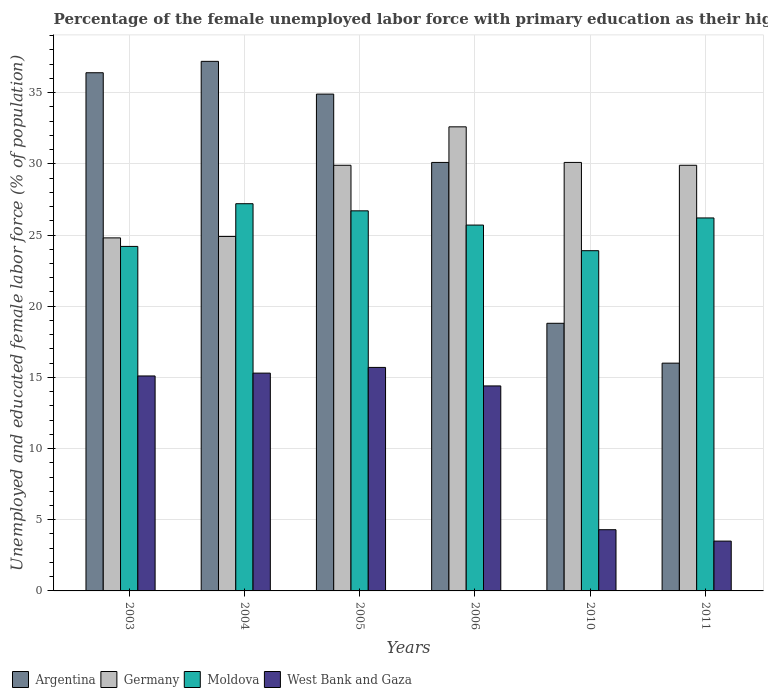How many different coloured bars are there?
Ensure brevity in your answer.  4. How many groups of bars are there?
Provide a short and direct response. 6. Are the number of bars on each tick of the X-axis equal?
Offer a terse response. Yes. How many bars are there on the 5th tick from the left?
Your answer should be compact. 4. What is the percentage of the unemployed female labor force with primary education in West Bank and Gaza in 2003?
Make the answer very short. 15.1. Across all years, what is the maximum percentage of the unemployed female labor force with primary education in Germany?
Ensure brevity in your answer.  32.6. In which year was the percentage of the unemployed female labor force with primary education in Moldova minimum?
Your response must be concise. 2010. What is the total percentage of the unemployed female labor force with primary education in West Bank and Gaza in the graph?
Your response must be concise. 68.3. What is the difference between the percentage of the unemployed female labor force with primary education in West Bank and Gaza in 2005 and that in 2011?
Provide a short and direct response. 12.2. What is the difference between the percentage of the unemployed female labor force with primary education in Germany in 2010 and the percentage of the unemployed female labor force with primary education in West Bank and Gaza in 2004?
Your answer should be very brief. 14.8. What is the average percentage of the unemployed female labor force with primary education in Moldova per year?
Ensure brevity in your answer.  25.65. In the year 2006, what is the difference between the percentage of the unemployed female labor force with primary education in Moldova and percentage of the unemployed female labor force with primary education in Argentina?
Keep it short and to the point. -4.4. In how many years, is the percentage of the unemployed female labor force with primary education in Germany greater than 28 %?
Provide a succinct answer. 4. What is the ratio of the percentage of the unemployed female labor force with primary education in West Bank and Gaza in 2010 to that in 2011?
Your answer should be very brief. 1.23. Is the difference between the percentage of the unemployed female labor force with primary education in Moldova in 2003 and 2006 greater than the difference between the percentage of the unemployed female labor force with primary education in Argentina in 2003 and 2006?
Provide a short and direct response. No. What is the difference between the highest and the second highest percentage of the unemployed female labor force with primary education in Moldova?
Keep it short and to the point. 0.5. What is the difference between the highest and the lowest percentage of the unemployed female labor force with primary education in Moldova?
Offer a very short reply. 3.3. Is it the case that in every year, the sum of the percentage of the unemployed female labor force with primary education in West Bank and Gaza and percentage of the unemployed female labor force with primary education in Argentina is greater than the sum of percentage of the unemployed female labor force with primary education in Germany and percentage of the unemployed female labor force with primary education in Moldova?
Keep it short and to the point. No. What does the 1st bar from the left in 2005 represents?
Ensure brevity in your answer.  Argentina. What is the difference between two consecutive major ticks on the Y-axis?
Your answer should be compact. 5. Where does the legend appear in the graph?
Keep it short and to the point. Bottom left. How many legend labels are there?
Keep it short and to the point. 4. How are the legend labels stacked?
Give a very brief answer. Horizontal. What is the title of the graph?
Provide a succinct answer. Percentage of the female unemployed labor force with primary education as their highest grade. What is the label or title of the X-axis?
Offer a terse response. Years. What is the label or title of the Y-axis?
Provide a succinct answer. Unemployed and educated female labor force (% of population). What is the Unemployed and educated female labor force (% of population) of Argentina in 2003?
Make the answer very short. 36.4. What is the Unemployed and educated female labor force (% of population) in Germany in 2003?
Keep it short and to the point. 24.8. What is the Unemployed and educated female labor force (% of population) in Moldova in 2003?
Give a very brief answer. 24.2. What is the Unemployed and educated female labor force (% of population) in West Bank and Gaza in 2003?
Offer a terse response. 15.1. What is the Unemployed and educated female labor force (% of population) of Argentina in 2004?
Your answer should be very brief. 37.2. What is the Unemployed and educated female labor force (% of population) of Germany in 2004?
Offer a very short reply. 24.9. What is the Unemployed and educated female labor force (% of population) in Moldova in 2004?
Offer a very short reply. 27.2. What is the Unemployed and educated female labor force (% of population) of West Bank and Gaza in 2004?
Ensure brevity in your answer.  15.3. What is the Unemployed and educated female labor force (% of population) of Argentina in 2005?
Offer a terse response. 34.9. What is the Unemployed and educated female labor force (% of population) of Germany in 2005?
Provide a short and direct response. 29.9. What is the Unemployed and educated female labor force (% of population) in Moldova in 2005?
Make the answer very short. 26.7. What is the Unemployed and educated female labor force (% of population) in West Bank and Gaza in 2005?
Offer a very short reply. 15.7. What is the Unemployed and educated female labor force (% of population) in Argentina in 2006?
Make the answer very short. 30.1. What is the Unemployed and educated female labor force (% of population) of Germany in 2006?
Provide a succinct answer. 32.6. What is the Unemployed and educated female labor force (% of population) of Moldova in 2006?
Make the answer very short. 25.7. What is the Unemployed and educated female labor force (% of population) of West Bank and Gaza in 2006?
Your answer should be compact. 14.4. What is the Unemployed and educated female labor force (% of population) of Argentina in 2010?
Make the answer very short. 18.8. What is the Unemployed and educated female labor force (% of population) of Germany in 2010?
Offer a terse response. 30.1. What is the Unemployed and educated female labor force (% of population) in Moldova in 2010?
Provide a short and direct response. 23.9. What is the Unemployed and educated female labor force (% of population) of West Bank and Gaza in 2010?
Ensure brevity in your answer.  4.3. What is the Unemployed and educated female labor force (% of population) in Germany in 2011?
Your answer should be very brief. 29.9. What is the Unemployed and educated female labor force (% of population) in Moldova in 2011?
Provide a succinct answer. 26.2. Across all years, what is the maximum Unemployed and educated female labor force (% of population) of Argentina?
Your answer should be very brief. 37.2. Across all years, what is the maximum Unemployed and educated female labor force (% of population) in Germany?
Provide a succinct answer. 32.6. Across all years, what is the maximum Unemployed and educated female labor force (% of population) in Moldova?
Your answer should be very brief. 27.2. Across all years, what is the maximum Unemployed and educated female labor force (% of population) of West Bank and Gaza?
Offer a very short reply. 15.7. Across all years, what is the minimum Unemployed and educated female labor force (% of population) in Germany?
Your answer should be very brief. 24.8. Across all years, what is the minimum Unemployed and educated female labor force (% of population) of Moldova?
Provide a short and direct response. 23.9. Across all years, what is the minimum Unemployed and educated female labor force (% of population) in West Bank and Gaza?
Keep it short and to the point. 3.5. What is the total Unemployed and educated female labor force (% of population) of Argentina in the graph?
Keep it short and to the point. 173.4. What is the total Unemployed and educated female labor force (% of population) in Germany in the graph?
Offer a very short reply. 172.2. What is the total Unemployed and educated female labor force (% of population) in Moldova in the graph?
Ensure brevity in your answer.  153.9. What is the total Unemployed and educated female labor force (% of population) of West Bank and Gaza in the graph?
Your response must be concise. 68.3. What is the difference between the Unemployed and educated female labor force (% of population) of Argentina in 2003 and that in 2004?
Offer a terse response. -0.8. What is the difference between the Unemployed and educated female labor force (% of population) of Germany in 2003 and that in 2004?
Ensure brevity in your answer.  -0.1. What is the difference between the Unemployed and educated female labor force (% of population) of West Bank and Gaza in 2003 and that in 2004?
Make the answer very short. -0.2. What is the difference between the Unemployed and educated female labor force (% of population) of Germany in 2003 and that in 2005?
Provide a succinct answer. -5.1. What is the difference between the Unemployed and educated female labor force (% of population) in Moldova in 2003 and that in 2006?
Your answer should be very brief. -1.5. What is the difference between the Unemployed and educated female labor force (% of population) in West Bank and Gaza in 2003 and that in 2006?
Your answer should be compact. 0.7. What is the difference between the Unemployed and educated female labor force (% of population) in Argentina in 2003 and that in 2010?
Make the answer very short. 17.6. What is the difference between the Unemployed and educated female labor force (% of population) in Germany in 2003 and that in 2010?
Give a very brief answer. -5.3. What is the difference between the Unemployed and educated female labor force (% of population) in Argentina in 2003 and that in 2011?
Your answer should be compact. 20.4. What is the difference between the Unemployed and educated female labor force (% of population) of Germany in 2003 and that in 2011?
Keep it short and to the point. -5.1. What is the difference between the Unemployed and educated female labor force (% of population) in Argentina in 2004 and that in 2005?
Make the answer very short. 2.3. What is the difference between the Unemployed and educated female labor force (% of population) in Moldova in 2004 and that in 2005?
Offer a very short reply. 0.5. What is the difference between the Unemployed and educated female labor force (% of population) of Argentina in 2004 and that in 2006?
Your answer should be compact. 7.1. What is the difference between the Unemployed and educated female labor force (% of population) of West Bank and Gaza in 2004 and that in 2006?
Provide a short and direct response. 0.9. What is the difference between the Unemployed and educated female labor force (% of population) of Argentina in 2004 and that in 2010?
Your response must be concise. 18.4. What is the difference between the Unemployed and educated female labor force (% of population) in Germany in 2004 and that in 2010?
Offer a very short reply. -5.2. What is the difference between the Unemployed and educated female labor force (% of population) in Moldova in 2004 and that in 2010?
Offer a terse response. 3.3. What is the difference between the Unemployed and educated female labor force (% of population) of Argentina in 2004 and that in 2011?
Keep it short and to the point. 21.2. What is the difference between the Unemployed and educated female labor force (% of population) of West Bank and Gaza in 2004 and that in 2011?
Provide a succinct answer. 11.8. What is the difference between the Unemployed and educated female labor force (% of population) of Moldova in 2005 and that in 2006?
Your answer should be very brief. 1. What is the difference between the Unemployed and educated female labor force (% of population) in West Bank and Gaza in 2005 and that in 2006?
Offer a terse response. 1.3. What is the difference between the Unemployed and educated female labor force (% of population) of Germany in 2005 and that in 2010?
Offer a very short reply. -0.2. What is the difference between the Unemployed and educated female labor force (% of population) in Moldova in 2005 and that in 2010?
Your response must be concise. 2.8. What is the difference between the Unemployed and educated female labor force (% of population) of West Bank and Gaza in 2005 and that in 2010?
Provide a short and direct response. 11.4. What is the difference between the Unemployed and educated female labor force (% of population) of Argentina in 2005 and that in 2011?
Offer a very short reply. 18.9. What is the difference between the Unemployed and educated female labor force (% of population) of Moldova in 2005 and that in 2011?
Give a very brief answer. 0.5. What is the difference between the Unemployed and educated female labor force (% of population) in Germany in 2006 and that in 2010?
Give a very brief answer. 2.5. What is the difference between the Unemployed and educated female labor force (% of population) of Moldova in 2006 and that in 2010?
Your answer should be very brief. 1.8. What is the difference between the Unemployed and educated female labor force (% of population) of West Bank and Gaza in 2006 and that in 2010?
Provide a succinct answer. 10.1. What is the difference between the Unemployed and educated female labor force (% of population) of Argentina in 2006 and that in 2011?
Your answer should be very brief. 14.1. What is the difference between the Unemployed and educated female labor force (% of population) in Argentina in 2010 and that in 2011?
Your response must be concise. 2.8. What is the difference between the Unemployed and educated female labor force (% of population) in Moldova in 2010 and that in 2011?
Ensure brevity in your answer.  -2.3. What is the difference between the Unemployed and educated female labor force (% of population) in West Bank and Gaza in 2010 and that in 2011?
Offer a very short reply. 0.8. What is the difference between the Unemployed and educated female labor force (% of population) of Argentina in 2003 and the Unemployed and educated female labor force (% of population) of West Bank and Gaza in 2004?
Your answer should be very brief. 21.1. What is the difference between the Unemployed and educated female labor force (% of population) in Germany in 2003 and the Unemployed and educated female labor force (% of population) in Moldova in 2004?
Ensure brevity in your answer.  -2.4. What is the difference between the Unemployed and educated female labor force (% of population) in Moldova in 2003 and the Unemployed and educated female labor force (% of population) in West Bank and Gaza in 2004?
Provide a succinct answer. 8.9. What is the difference between the Unemployed and educated female labor force (% of population) of Argentina in 2003 and the Unemployed and educated female labor force (% of population) of Germany in 2005?
Make the answer very short. 6.5. What is the difference between the Unemployed and educated female labor force (% of population) of Argentina in 2003 and the Unemployed and educated female labor force (% of population) of Moldova in 2005?
Provide a short and direct response. 9.7. What is the difference between the Unemployed and educated female labor force (% of population) of Argentina in 2003 and the Unemployed and educated female labor force (% of population) of West Bank and Gaza in 2005?
Your answer should be compact. 20.7. What is the difference between the Unemployed and educated female labor force (% of population) of Germany in 2003 and the Unemployed and educated female labor force (% of population) of West Bank and Gaza in 2006?
Provide a short and direct response. 10.4. What is the difference between the Unemployed and educated female labor force (% of population) in Moldova in 2003 and the Unemployed and educated female labor force (% of population) in West Bank and Gaza in 2006?
Offer a very short reply. 9.8. What is the difference between the Unemployed and educated female labor force (% of population) in Argentina in 2003 and the Unemployed and educated female labor force (% of population) in Germany in 2010?
Offer a very short reply. 6.3. What is the difference between the Unemployed and educated female labor force (% of population) of Argentina in 2003 and the Unemployed and educated female labor force (% of population) of West Bank and Gaza in 2010?
Ensure brevity in your answer.  32.1. What is the difference between the Unemployed and educated female labor force (% of population) in Moldova in 2003 and the Unemployed and educated female labor force (% of population) in West Bank and Gaza in 2010?
Ensure brevity in your answer.  19.9. What is the difference between the Unemployed and educated female labor force (% of population) in Argentina in 2003 and the Unemployed and educated female labor force (% of population) in Germany in 2011?
Provide a succinct answer. 6.5. What is the difference between the Unemployed and educated female labor force (% of population) in Argentina in 2003 and the Unemployed and educated female labor force (% of population) in West Bank and Gaza in 2011?
Your answer should be compact. 32.9. What is the difference between the Unemployed and educated female labor force (% of population) in Germany in 2003 and the Unemployed and educated female labor force (% of population) in Moldova in 2011?
Your answer should be compact. -1.4. What is the difference between the Unemployed and educated female labor force (% of population) in Germany in 2003 and the Unemployed and educated female labor force (% of population) in West Bank and Gaza in 2011?
Offer a terse response. 21.3. What is the difference between the Unemployed and educated female labor force (% of population) of Moldova in 2003 and the Unemployed and educated female labor force (% of population) of West Bank and Gaza in 2011?
Give a very brief answer. 20.7. What is the difference between the Unemployed and educated female labor force (% of population) in Argentina in 2004 and the Unemployed and educated female labor force (% of population) in Germany in 2005?
Give a very brief answer. 7.3. What is the difference between the Unemployed and educated female labor force (% of population) in Argentina in 2004 and the Unemployed and educated female labor force (% of population) in West Bank and Gaza in 2005?
Make the answer very short. 21.5. What is the difference between the Unemployed and educated female labor force (% of population) of Moldova in 2004 and the Unemployed and educated female labor force (% of population) of West Bank and Gaza in 2005?
Make the answer very short. 11.5. What is the difference between the Unemployed and educated female labor force (% of population) in Argentina in 2004 and the Unemployed and educated female labor force (% of population) in West Bank and Gaza in 2006?
Make the answer very short. 22.8. What is the difference between the Unemployed and educated female labor force (% of population) of Germany in 2004 and the Unemployed and educated female labor force (% of population) of Moldova in 2006?
Make the answer very short. -0.8. What is the difference between the Unemployed and educated female labor force (% of population) in Germany in 2004 and the Unemployed and educated female labor force (% of population) in West Bank and Gaza in 2006?
Your answer should be very brief. 10.5. What is the difference between the Unemployed and educated female labor force (% of population) of Moldova in 2004 and the Unemployed and educated female labor force (% of population) of West Bank and Gaza in 2006?
Your response must be concise. 12.8. What is the difference between the Unemployed and educated female labor force (% of population) in Argentina in 2004 and the Unemployed and educated female labor force (% of population) in Germany in 2010?
Ensure brevity in your answer.  7.1. What is the difference between the Unemployed and educated female labor force (% of population) of Argentina in 2004 and the Unemployed and educated female labor force (% of population) of West Bank and Gaza in 2010?
Keep it short and to the point. 32.9. What is the difference between the Unemployed and educated female labor force (% of population) in Germany in 2004 and the Unemployed and educated female labor force (% of population) in West Bank and Gaza in 2010?
Offer a very short reply. 20.6. What is the difference between the Unemployed and educated female labor force (% of population) of Moldova in 2004 and the Unemployed and educated female labor force (% of population) of West Bank and Gaza in 2010?
Your answer should be very brief. 22.9. What is the difference between the Unemployed and educated female labor force (% of population) of Argentina in 2004 and the Unemployed and educated female labor force (% of population) of Germany in 2011?
Your answer should be compact. 7.3. What is the difference between the Unemployed and educated female labor force (% of population) in Argentina in 2004 and the Unemployed and educated female labor force (% of population) in Moldova in 2011?
Provide a short and direct response. 11. What is the difference between the Unemployed and educated female labor force (% of population) in Argentina in 2004 and the Unemployed and educated female labor force (% of population) in West Bank and Gaza in 2011?
Your answer should be very brief. 33.7. What is the difference between the Unemployed and educated female labor force (% of population) of Germany in 2004 and the Unemployed and educated female labor force (% of population) of Moldova in 2011?
Provide a short and direct response. -1.3. What is the difference between the Unemployed and educated female labor force (% of population) in Germany in 2004 and the Unemployed and educated female labor force (% of population) in West Bank and Gaza in 2011?
Keep it short and to the point. 21.4. What is the difference between the Unemployed and educated female labor force (% of population) of Moldova in 2004 and the Unemployed and educated female labor force (% of population) of West Bank and Gaza in 2011?
Give a very brief answer. 23.7. What is the difference between the Unemployed and educated female labor force (% of population) of Argentina in 2005 and the Unemployed and educated female labor force (% of population) of Germany in 2006?
Offer a terse response. 2.3. What is the difference between the Unemployed and educated female labor force (% of population) in Argentina in 2005 and the Unemployed and educated female labor force (% of population) in Moldova in 2006?
Provide a short and direct response. 9.2. What is the difference between the Unemployed and educated female labor force (% of population) of Argentina in 2005 and the Unemployed and educated female labor force (% of population) of Moldova in 2010?
Ensure brevity in your answer.  11. What is the difference between the Unemployed and educated female labor force (% of population) of Argentina in 2005 and the Unemployed and educated female labor force (% of population) of West Bank and Gaza in 2010?
Keep it short and to the point. 30.6. What is the difference between the Unemployed and educated female labor force (% of population) in Germany in 2005 and the Unemployed and educated female labor force (% of population) in Moldova in 2010?
Offer a very short reply. 6. What is the difference between the Unemployed and educated female labor force (% of population) of Germany in 2005 and the Unemployed and educated female labor force (% of population) of West Bank and Gaza in 2010?
Make the answer very short. 25.6. What is the difference between the Unemployed and educated female labor force (% of population) in Moldova in 2005 and the Unemployed and educated female labor force (% of population) in West Bank and Gaza in 2010?
Provide a short and direct response. 22.4. What is the difference between the Unemployed and educated female labor force (% of population) in Argentina in 2005 and the Unemployed and educated female labor force (% of population) in Germany in 2011?
Keep it short and to the point. 5. What is the difference between the Unemployed and educated female labor force (% of population) in Argentina in 2005 and the Unemployed and educated female labor force (% of population) in Moldova in 2011?
Your answer should be compact. 8.7. What is the difference between the Unemployed and educated female labor force (% of population) in Argentina in 2005 and the Unemployed and educated female labor force (% of population) in West Bank and Gaza in 2011?
Offer a terse response. 31.4. What is the difference between the Unemployed and educated female labor force (% of population) of Germany in 2005 and the Unemployed and educated female labor force (% of population) of West Bank and Gaza in 2011?
Your answer should be compact. 26.4. What is the difference between the Unemployed and educated female labor force (% of population) in Moldova in 2005 and the Unemployed and educated female labor force (% of population) in West Bank and Gaza in 2011?
Ensure brevity in your answer.  23.2. What is the difference between the Unemployed and educated female labor force (% of population) of Argentina in 2006 and the Unemployed and educated female labor force (% of population) of Germany in 2010?
Give a very brief answer. 0. What is the difference between the Unemployed and educated female labor force (% of population) of Argentina in 2006 and the Unemployed and educated female labor force (% of population) of Moldova in 2010?
Make the answer very short. 6.2. What is the difference between the Unemployed and educated female labor force (% of population) of Argentina in 2006 and the Unemployed and educated female labor force (% of population) of West Bank and Gaza in 2010?
Your response must be concise. 25.8. What is the difference between the Unemployed and educated female labor force (% of population) of Germany in 2006 and the Unemployed and educated female labor force (% of population) of Moldova in 2010?
Make the answer very short. 8.7. What is the difference between the Unemployed and educated female labor force (% of population) of Germany in 2006 and the Unemployed and educated female labor force (% of population) of West Bank and Gaza in 2010?
Ensure brevity in your answer.  28.3. What is the difference between the Unemployed and educated female labor force (% of population) in Moldova in 2006 and the Unemployed and educated female labor force (% of population) in West Bank and Gaza in 2010?
Offer a very short reply. 21.4. What is the difference between the Unemployed and educated female labor force (% of population) in Argentina in 2006 and the Unemployed and educated female labor force (% of population) in West Bank and Gaza in 2011?
Your answer should be very brief. 26.6. What is the difference between the Unemployed and educated female labor force (% of population) of Germany in 2006 and the Unemployed and educated female labor force (% of population) of Moldova in 2011?
Offer a terse response. 6.4. What is the difference between the Unemployed and educated female labor force (% of population) of Germany in 2006 and the Unemployed and educated female labor force (% of population) of West Bank and Gaza in 2011?
Your response must be concise. 29.1. What is the difference between the Unemployed and educated female labor force (% of population) in Moldova in 2006 and the Unemployed and educated female labor force (% of population) in West Bank and Gaza in 2011?
Make the answer very short. 22.2. What is the difference between the Unemployed and educated female labor force (% of population) of Argentina in 2010 and the Unemployed and educated female labor force (% of population) of Germany in 2011?
Ensure brevity in your answer.  -11.1. What is the difference between the Unemployed and educated female labor force (% of population) in Argentina in 2010 and the Unemployed and educated female labor force (% of population) in West Bank and Gaza in 2011?
Provide a short and direct response. 15.3. What is the difference between the Unemployed and educated female labor force (% of population) of Germany in 2010 and the Unemployed and educated female labor force (% of population) of Moldova in 2011?
Provide a succinct answer. 3.9. What is the difference between the Unemployed and educated female labor force (% of population) in Germany in 2010 and the Unemployed and educated female labor force (% of population) in West Bank and Gaza in 2011?
Your answer should be compact. 26.6. What is the difference between the Unemployed and educated female labor force (% of population) in Moldova in 2010 and the Unemployed and educated female labor force (% of population) in West Bank and Gaza in 2011?
Give a very brief answer. 20.4. What is the average Unemployed and educated female labor force (% of population) of Argentina per year?
Provide a succinct answer. 28.9. What is the average Unemployed and educated female labor force (% of population) of Germany per year?
Your answer should be compact. 28.7. What is the average Unemployed and educated female labor force (% of population) in Moldova per year?
Your response must be concise. 25.65. What is the average Unemployed and educated female labor force (% of population) in West Bank and Gaza per year?
Provide a succinct answer. 11.38. In the year 2003, what is the difference between the Unemployed and educated female labor force (% of population) in Argentina and Unemployed and educated female labor force (% of population) in West Bank and Gaza?
Ensure brevity in your answer.  21.3. In the year 2003, what is the difference between the Unemployed and educated female labor force (% of population) in Germany and Unemployed and educated female labor force (% of population) in Moldova?
Your answer should be compact. 0.6. In the year 2003, what is the difference between the Unemployed and educated female labor force (% of population) of Germany and Unemployed and educated female labor force (% of population) of West Bank and Gaza?
Provide a short and direct response. 9.7. In the year 2004, what is the difference between the Unemployed and educated female labor force (% of population) in Argentina and Unemployed and educated female labor force (% of population) in Germany?
Provide a succinct answer. 12.3. In the year 2004, what is the difference between the Unemployed and educated female labor force (% of population) of Argentina and Unemployed and educated female labor force (% of population) of West Bank and Gaza?
Your response must be concise. 21.9. In the year 2004, what is the difference between the Unemployed and educated female labor force (% of population) of Germany and Unemployed and educated female labor force (% of population) of West Bank and Gaza?
Offer a very short reply. 9.6. In the year 2004, what is the difference between the Unemployed and educated female labor force (% of population) in Moldova and Unemployed and educated female labor force (% of population) in West Bank and Gaza?
Your response must be concise. 11.9. In the year 2005, what is the difference between the Unemployed and educated female labor force (% of population) of Argentina and Unemployed and educated female labor force (% of population) of Germany?
Your answer should be very brief. 5. In the year 2005, what is the difference between the Unemployed and educated female labor force (% of population) of Argentina and Unemployed and educated female labor force (% of population) of Moldova?
Provide a succinct answer. 8.2. In the year 2005, what is the difference between the Unemployed and educated female labor force (% of population) in Argentina and Unemployed and educated female labor force (% of population) in West Bank and Gaza?
Provide a short and direct response. 19.2. In the year 2005, what is the difference between the Unemployed and educated female labor force (% of population) in Germany and Unemployed and educated female labor force (% of population) in West Bank and Gaza?
Your answer should be very brief. 14.2. In the year 2005, what is the difference between the Unemployed and educated female labor force (% of population) in Moldova and Unemployed and educated female labor force (% of population) in West Bank and Gaza?
Offer a terse response. 11. In the year 2006, what is the difference between the Unemployed and educated female labor force (% of population) in Argentina and Unemployed and educated female labor force (% of population) in Germany?
Provide a succinct answer. -2.5. In the year 2006, what is the difference between the Unemployed and educated female labor force (% of population) in Argentina and Unemployed and educated female labor force (% of population) in Moldova?
Offer a terse response. 4.4. In the year 2006, what is the difference between the Unemployed and educated female labor force (% of population) of Germany and Unemployed and educated female labor force (% of population) of Moldova?
Your response must be concise. 6.9. In the year 2010, what is the difference between the Unemployed and educated female labor force (% of population) of Argentina and Unemployed and educated female labor force (% of population) of Moldova?
Your answer should be compact. -5.1. In the year 2010, what is the difference between the Unemployed and educated female labor force (% of population) in Germany and Unemployed and educated female labor force (% of population) in Moldova?
Offer a very short reply. 6.2. In the year 2010, what is the difference between the Unemployed and educated female labor force (% of population) in Germany and Unemployed and educated female labor force (% of population) in West Bank and Gaza?
Make the answer very short. 25.8. In the year 2010, what is the difference between the Unemployed and educated female labor force (% of population) in Moldova and Unemployed and educated female labor force (% of population) in West Bank and Gaza?
Your response must be concise. 19.6. In the year 2011, what is the difference between the Unemployed and educated female labor force (% of population) of Argentina and Unemployed and educated female labor force (% of population) of Germany?
Your response must be concise. -13.9. In the year 2011, what is the difference between the Unemployed and educated female labor force (% of population) of Argentina and Unemployed and educated female labor force (% of population) of Moldova?
Offer a very short reply. -10.2. In the year 2011, what is the difference between the Unemployed and educated female labor force (% of population) of Germany and Unemployed and educated female labor force (% of population) of West Bank and Gaza?
Make the answer very short. 26.4. In the year 2011, what is the difference between the Unemployed and educated female labor force (% of population) of Moldova and Unemployed and educated female labor force (% of population) of West Bank and Gaza?
Your answer should be very brief. 22.7. What is the ratio of the Unemployed and educated female labor force (% of population) of Argentina in 2003 to that in 2004?
Provide a short and direct response. 0.98. What is the ratio of the Unemployed and educated female labor force (% of population) of Germany in 2003 to that in 2004?
Keep it short and to the point. 1. What is the ratio of the Unemployed and educated female labor force (% of population) of Moldova in 2003 to that in 2004?
Your response must be concise. 0.89. What is the ratio of the Unemployed and educated female labor force (% of population) in West Bank and Gaza in 2003 to that in 2004?
Your answer should be very brief. 0.99. What is the ratio of the Unemployed and educated female labor force (% of population) in Argentina in 2003 to that in 2005?
Your response must be concise. 1.04. What is the ratio of the Unemployed and educated female labor force (% of population) of Germany in 2003 to that in 2005?
Your answer should be compact. 0.83. What is the ratio of the Unemployed and educated female labor force (% of population) of Moldova in 2003 to that in 2005?
Ensure brevity in your answer.  0.91. What is the ratio of the Unemployed and educated female labor force (% of population) of West Bank and Gaza in 2003 to that in 2005?
Your response must be concise. 0.96. What is the ratio of the Unemployed and educated female labor force (% of population) of Argentina in 2003 to that in 2006?
Your response must be concise. 1.21. What is the ratio of the Unemployed and educated female labor force (% of population) in Germany in 2003 to that in 2006?
Provide a succinct answer. 0.76. What is the ratio of the Unemployed and educated female labor force (% of population) in Moldova in 2003 to that in 2006?
Ensure brevity in your answer.  0.94. What is the ratio of the Unemployed and educated female labor force (% of population) in West Bank and Gaza in 2003 to that in 2006?
Keep it short and to the point. 1.05. What is the ratio of the Unemployed and educated female labor force (% of population) of Argentina in 2003 to that in 2010?
Your response must be concise. 1.94. What is the ratio of the Unemployed and educated female labor force (% of population) of Germany in 2003 to that in 2010?
Ensure brevity in your answer.  0.82. What is the ratio of the Unemployed and educated female labor force (% of population) in Moldova in 2003 to that in 2010?
Your answer should be compact. 1.01. What is the ratio of the Unemployed and educated female labor force (% of population) in West Bank and Gaza in 2003 to that in 2010?
Your answer should be very brief. 3.51. What is the ratio of the Unemployed and educated female labor force (% of population) of Argentina in 2003 to that in 2011?
Offer a terse response. 2.27. What is the ratio of the Unemployed and educated female labor force (% of population) of Germany in 2003 to that in 2011?
Offer a very short reply. 0.83. What is the ratio of the Unemployed and educated female labor force (% of population) of Moldova in 2003 to that in 2011?
Keep it short and to the point. 0.92. What is the ratio of the Unemployed and educated female labor force (% of population) in West Bank and Gaza in 2003 to that in 2011?
Your answer should be very brief. 4.31. What is the ratio of the Unemployed and educated female labor force (% of population) of Argentina in 2004 to that in 2005?
Your answer should be compact. 1.07. What is the ratio of the Unemployed and educated female labor force (% of population) of Germany in 2004 to that in 2005?
Keep it short and to the point. 0.83. What is the ratio of the Unemployed and educated female labor force (% of population) of Moldova in 2004 to that in 2005?
Your answer should be very brief. 1.02. What is the ratio of the Unemployed and educated female labor force (% of population) of West Bank and Gaza in 2004 to that in 2005?
Your response must be concise. 0.97. What is the ratio of the Unemployed and educated female labor force (% of population) of Argentina in 2004 to that in 2006?
Offer a very short reply. 1.24. What is the ratio of the Unemployed and educated female labor force (% of population) of Germany in 2004 to that in 2006?
Ensure brevity in your answer.  0.76. What is the ratio of the Unemployed and educated female labor force (% of population) of Moldova in 2004 to that in 2006?
Give a very brief answer. 1.06. What is the ratio of the Unemployed and educated female labor force (% of population) of West Bank and Gaza in 2004 to that in 2006?
Your response must be concise. 1.06. What is the ratio of the Unemployed and educated female labor force (% of population) in Argentina in 2004 to that in 2010?
Your answer should be very brief. 1.98. What is the ratio of the Unemployed and educated female labor force (% of population) in Germany in 2004 to that in 2010?
Keep it short and to the point. 0.83. What is the ratio of the Unemployed and educated female labor force (% of population) of Moldova in 2004 to that in 2010?
Your response must be concise. 1.14. What is the ratio of the Unemployed and educated female labor force (% of population) in West Bank and Gaza in 2004 to that in 2010?
Make the answer very short. 3.56. What is the ratio of the Unemployed and educated female labor force (% of population) in Argentina in 2004 to that in 2011?
Ensure brevity in your answer.  2.33. What is the ratio of the Unemployed and educated female labor force (% of population) in Germany in 2004 to that in 2011?
Offer a very short reply. 0.83. What is the ratio of the Unemployed and educated female labor force (% of population) of Moldova in 2004 to that in 2011?
Keep it short and to the point. 1.04. What is the ratio of the Unemployed and educated female labor force (% of population) in West Bank and Gaza in 2004 to that in 2011?
Your answer should be very brief. 4.37. What is the ratio of the Unemployed and educated female labor force (% of population) of Argentina in 2005 to that in 2006?
Keep it short and to the point. 1.16. What is the ratio of the Unemployed and educated female labor force (% of population) of Germany in 2005 to that in 2006?
Your answer should be very brief. 0.92. What is the ratio of the Unemployed and educated female labor force (% of population) of Moldova in 2005 to that in 2006?
Provide a short and direct response. 1.04. What is the ratio of the Unemployed and educated female labor force (% of population) of West Bank and Gaza in 2005 to that in 2006?
Provide a short and direct response. 1.09. What is the ratio of the Unemployed and educated female labor force (% of population) of Argentina in 2005 to that in 2010?
Provide a short and direct response. 1.86. What is the ratio of the Unemployed and educated female labor force (% of population) of Germany in 2005 to that in 2010?
Offer a terse response. 0.99. What is the ratio of the Unemployed and educated female labor force (% of population) in Moldova in 2005 to that in 2010?
Your answer should be very brief. 1.12. What is the ratio of the Unemployed and educated female labor force (% of population) of West Bank and Gaza in 2005 to that in 2010?
Give a very brief answer. 3.65. What is the ratio of the Unemployed and educated female labor force (% of population) of Argentina in 2005 to that in 2011?
Your answer should be compact. 2.18. What is the ratio of the Unemployed and educated female labor force (% of population) in Germany in 2005 to that in 2011?
Your answer should be very brief. 1. What is the ratio of the Unemployed and educated female labor force (% of population) of Moldova in 2005 to that in 2011?
Provide a succinct answer. 1.02. What is the ratio of the Unemployed and educated female labor force (% of population) in West Bank and Gaza in 2005 to that in 2011?
Your answer should be compact. 4.49. What is the ratio of the Unemployed and educated female labor force (% of population) of Argentina in 2006 to that in 2010?
Offer a terse response. 1.6. What is the ratio of the Unemployed and educated female labor force (% of population) in Germany in 2006 to that in 2010?
Your answer should be compact. 1.08. What is the ratio of the Unemployed and educated female labor force (% of population) in Moldova in 2006 to that in 2010?
Offer a very short reply. 1.08. What is the ratio of the Unemployed and educated female labor force (% of population) in West Bank and Gaza in 2006 to that in 2010?
Ensure brevity in your answer.  3.35. What is the ratio of the Unemployed and educated female labor force (% of population) in Argentina in 2006 to that in 2011?
Your answer should be compact. 1.88. What is the ratio of the Unemployed and educated female labor force (% of population) of Germany in 2006 to that in 2011?
Ensure brevity in your answer.  1.09. What is the ratio of the Unemployed and educated female labor force (% of population) in Moldova in 2006 to that in 2011?
Ensure brevity in your answer.  0.98. What is the ratio of the Unemployed and educated female labor force (% of population) in West Bank and Gaza in 2006 to that in 2011?
Your response must be concise. 4.11. What is the ratio of the Unemployed and educated female labor force (% of population) in Argentina in 2010 to that in 2011?
Offer a terse response. 1.18. What is the ratio of the Unemployed and educated female labor force (% of population) of Germany in 2010 to that in 2011?
Provide a short and direct response. 1.01. What is the ratio of the Unemployed and educated female labor force (% of population) in Moldova in 2010 to that in 2011?
Give a very brief answer. 0.91. What is the ratio of the Unemployed and educated female labor force (% of population) in West Bank and Gaza in 2010 to that in 2011?
Give a very brief answer. 1.23. What is the difference between the highest and the second highest Unemployed and educated female labor force (% of population) of Argentina?
Your answer should be very brief. 0.8. What is the difference between the highest and the second highest Unemployed and educated female labor force (% of population) of Germany?
Offer a very short reply. 2.5. What is the difference between the highest and the lowest Unemployed and educated female labor force (% of population) of Argentina?
Ensure brevity in your answer.  21.2. 